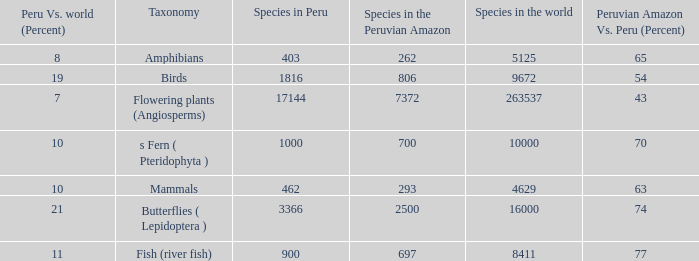What's the minimum species in the peruvian amazon with peru vs. world (percent) value of 7 7372.0. 